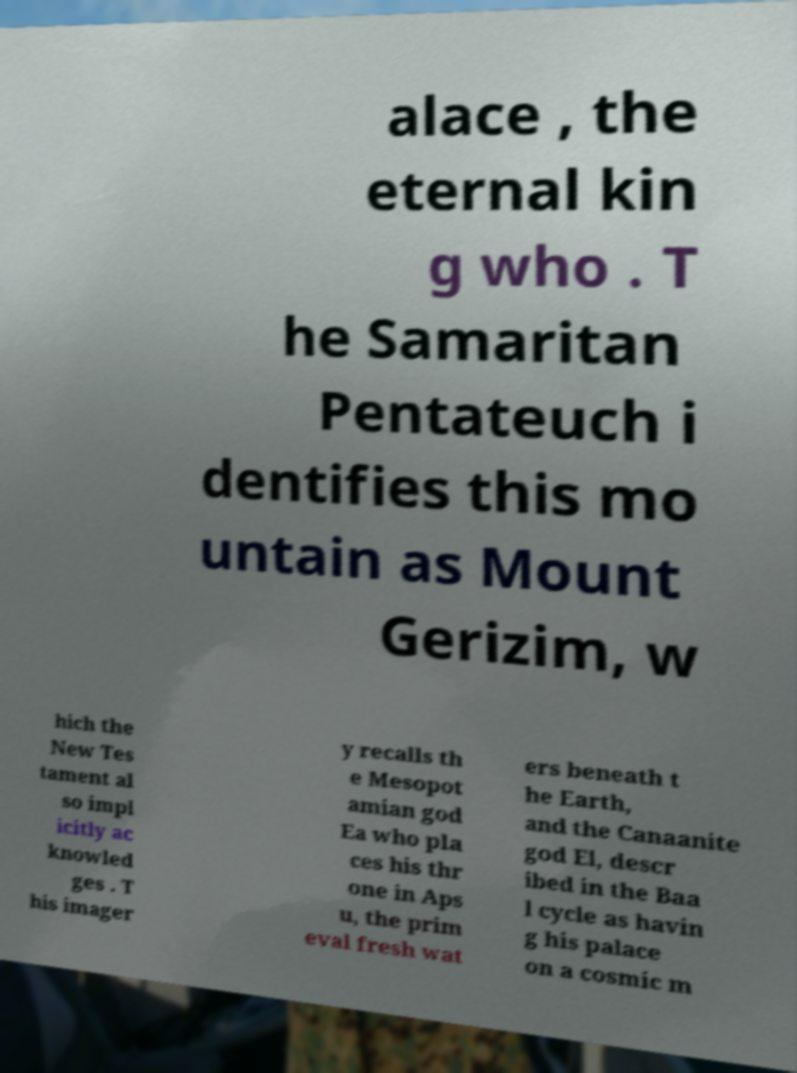Could you extract and type out the text from this image? alace , the eternal kin g who . T he Samaritan Pentateuch i dentifies this mo untain as Mount Gerizim, w hich the New Tes tament al so impl icitly ac knowled ges . T his imager y recalls th e Mesopot amian god Ea who pla ces his thr one in Aps u, the prim eval fresh wat ers beneath t he Earth, and the Canaanite god El, descr ibed in the Baa l cycle as havin g his palace on a cosmic m 